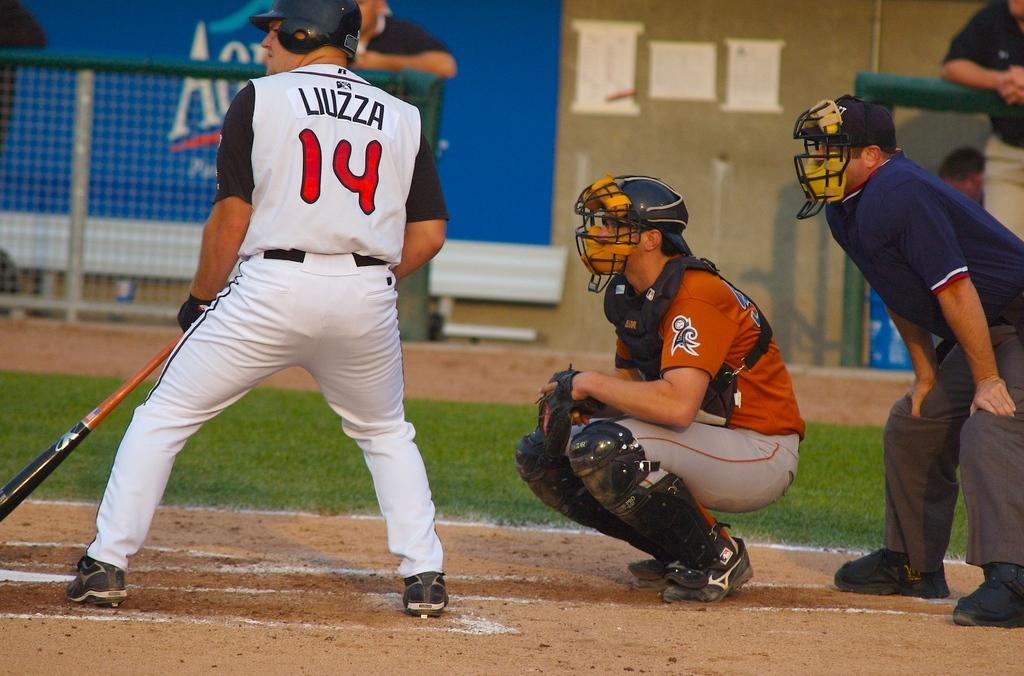<image>
Render a clear and concise summary of the photo. Baseball player Liuzza is standing at the batting plate with the catcher and umpire behind him. 